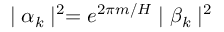<formula> <loc_0><loc_0><loc_500><loc_500>| \alpha _ { k } | ^ { 2 } = e ^ { 2 \pi m / H } | \beta _ { k } | ^ { 2 }</formula> 